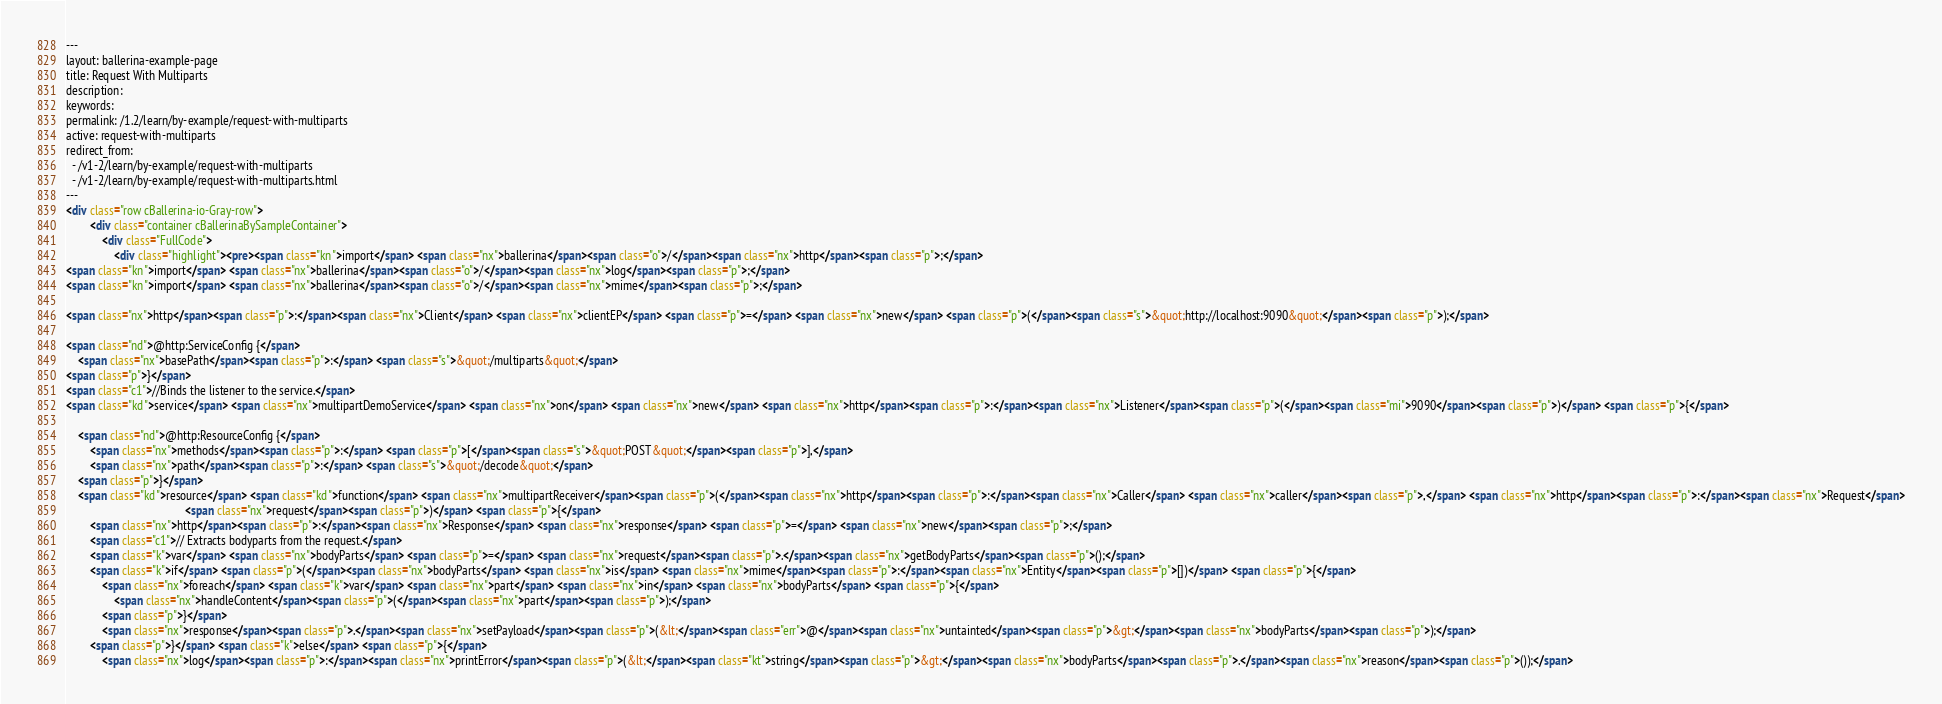Convert code to text. <code><loc_0><loc_0><loc_500><loc_500><_HTML_>---
layout: ballerina-example-page
title: Request With Multiparts
description: 
keywords: 
permalink: /1.2/learn/by-example/request-with-multiparts
active: request-with-multiparts
redirect_from:
  - /v1-2/learn/by-example/request-with-multiparts
  - /v1-2/learn/by-example/request-with-multiparts.html
---
<div class="row cBallerina-io-Gray-row">
        <div class="container cBallerinaBySampleContainer">
            <div class="FullCode">
                <div class="highlight"><pre><span class="kn">import</span> <span class="nx">ballerina</span><span class="o">/</span><span class="nx">http</span><span class="p">;</span>
<span class="kn">import</span> <span class="nx">ballerina</span><span class="o">/</span><span class="nx">log</span><span class="p">;</span>
<span class="kn">import</span> <span class="nx">ballerina</span><span class="o">/</span><span class="nx">mime</span><span class="p">;</span>

<span class="nx">http</span><span class="p">:</span><span class="nx">Client</span> <span class="nx">clientEP</span> <span class="p">=</span> <span class="nx">new</span> <span class="p">(</span><span class="s">&quot;http://localhost:9090&quot;</span><span class="p">);</span>

<span class="nd">@http:ServiceConfig {</span>
    <span class="nx">basePath</span><span class="p">:</span> <span class="s">&quot;/multiparts&quot;</span>
<span class="p">}</span>
<span class="c1">//Binds the listener to the service.</span>
<span class="kd">service</span> <span class="nx">multipartDemoService</span> <span class="nx">on</span> <span class="nx">new</span> <span class="nx">http</span><span class="p">:</span><span class="nx">Listener</span><span class="p">(</span><span class="mi">9090</span><span class="p">)</span> <span class="p">{</span>

    <span class="nd">@http:ResourceConfig {</span>
        <span class="nx">methods</span><span class="p">:</span> <span class="p">[</span><span class="s">&quot;POST&quot;</span><span class="p">],</span>
        <span class="nx">path</span><span class="p">:</span> <span class="s">&quot;/decode&quot;</span>
    <span class="p">}</span>
    <span class="kd">resource</span> <span class="kd">function</span> <span class="nx">multipartReceiver</span><span class="p">(</span><span class="nx">http</span><span class="p">:</span><span class="nx">Caller</span> <span class="nx">caller</span><span class="p">,</span> <span class="nx">http</span><span class="p">:</span><span class="nx">Request</span>
                                        <span class="nx">request</span><span class="p">)</span> <span class="p">{</span>
        <span class="nx">http</span><span class="p">:</span><span class="nx">Response</span> <span class="nx">response</span> <span class="p">=</span> <span class="nx">new</span><span class="p">;</span>
        <span class="c1">// Extracts bodyparts from the request.</span>
        <span class="k">var</span> <span class="nx">bodyParts</span> <span class="p">=</span> <span class="nx">request</span><span class="p">.</span><span class="nx">getBodyParts</span><span class="p">();</span>
        <span class="k">if</span> <span class="p">(</span><span class="nx">bodyParts</span> <span class="nx">is</span> <span class="nx">mime</span><span class="p">:</span><span class="nx">Entity</span><span class="p">[])</span> <span class="p">{</span>
            <span class="nx">foreach</span> <span class="k">var</span> <span class="nx">part</span> <span class="nx">in</span> <span class="nx">bodyParts</span> <span class="p">{</span>
                <span class="nx">handleContent</span><span class="p">(</span><span class="nx">part</span><span class="p">);</span>
            <span class="p">}</span>
            <span class="nx">response</span><span class="p">.</span><span class="nx">setPayload</span><span class="p">(&lt;</span><span class="err">@</span><span class="nx">untainted</span><span class="p">&gt;</span><span class="nx">bodyParts</span><span class="p">);</span>
        <span class="p">}</span> <span class="k">else</span> <span class="p">{</span>
            <span class="nx">log</span><span class="p">:</span><span class="nx">printError</span><span class="p">(&lt;</span><span class="kt">string</span><span class="p">&gt;</span><span class="nx">bodyParts</span><span class="p">.</span><span class="nx">reason</span><span class="p">());</span></code> 